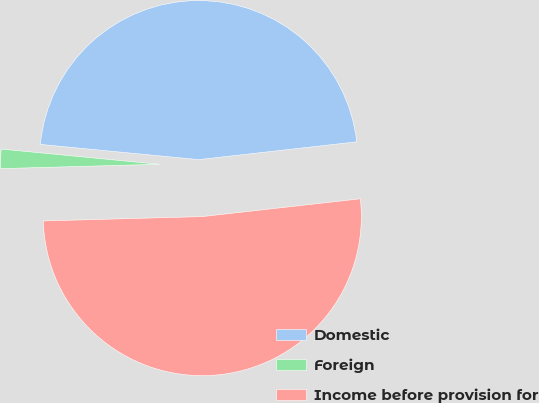Convert chart. <chart><loc_0><loc_0><loc_500><loc_500><pie_chart><fcel>Domestic<fcel>Foreign<fcel>Income before provision for<nl><fcel>46.69%<fcel>1.96%<fcel>51.35%<nl></chart> 